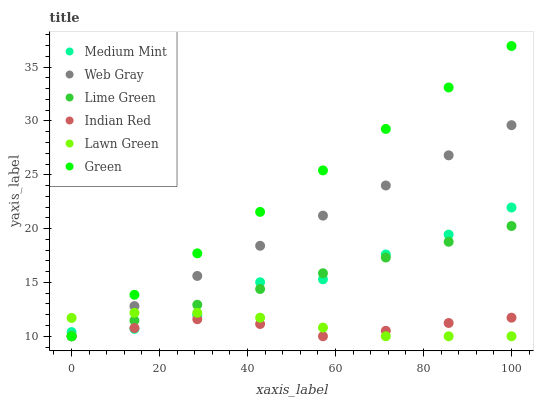Does Indian Red have the minimum area under the curve?
Answer yes or no. Yes. Does Green have the maximum area under the curve?
Answer yes or no. Yes. Does Lawn Green have the minimum area under the curve?
Answer yes or no. No. Does Lawn Green have the maximum area under the curve?
Answer yes or no. No. Is Green the smoothest?
Answer yes or no. Yes. Is Medium Mint the roughest?
Answer yes or no. Yes. Is Lawn Green the smoothest?
Answer yes or no. No. Is Lawn Green the roughest?
Answer yes or no. No. Does Lawn Green have the lowest value?
Answer yes or no. Yes. Does Green have the highest value?
Answer yes or no. Yes. Does Lawn Green have the highest value?
Answer yes or no. No. Does Indian Red intersect Lime Green?
Answer yes or no. Yes. Is Indian Red less than Lime Green?
Answer yes or no. No. Is Indian Red greater than Lime Green?
Answer yes or no. No. 